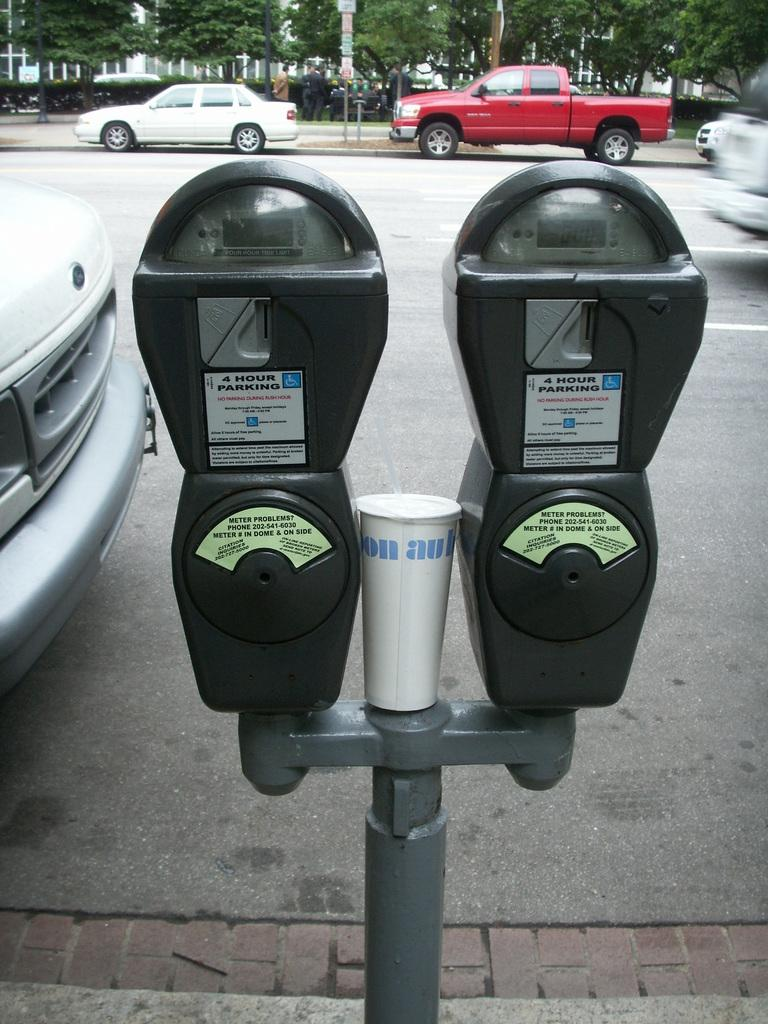Provide a one-sentence caption for the provided image. A double parking meter that says if you have problems call 202-541-6030. 